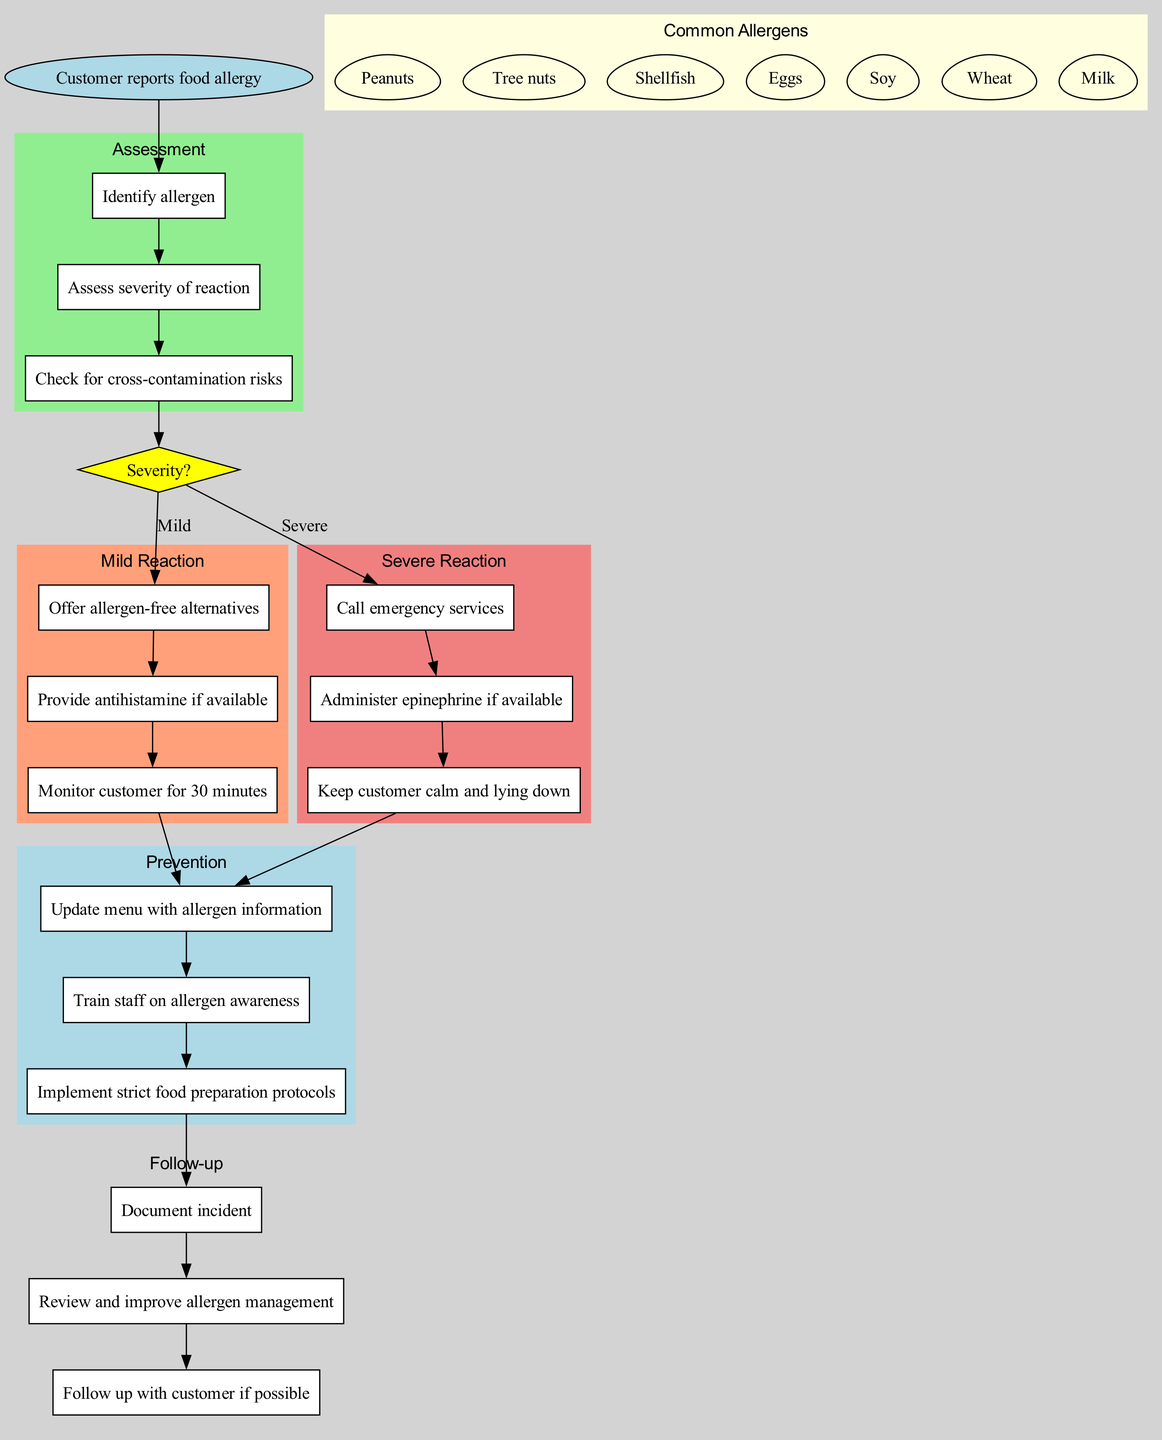What is the starting point of the clinical pathway? The starting point is explicitly defined in the diagram as "Customer reports food allergy," marking the initial entry into the clinical pathway.
Answer: Customer reports food allergy How many assessment steps are there? By counting the listed assessment steps under the "Assessment" cluster, there are three steps to be followed.
Answer: 3 What are the actions to take in case of a mild reaction? The diagram lists three specific actions to take for a mild reaction, providing a clear sequence to follow in this scenario.
Answer: Offer allergen-free alternatives, Provide antihistamine if available, Monitor customer for 30 minutes What is the first action to take for a severe reaction? The diagram indicates that the very first action to take in the severe reaction pathway is to "Call emergency services," making it the top priority in this situation.
Answer: Call emergency services What is the connection between mild reactions and prevention steps? The diagram shows that, after completing the actions for a mild reaction, there is a direct link from the last action in the mild reaction to the first prevention step. This indicates that prevention steps are intended to follow after addressing mild reactions.
Answer: Direct link to prevention steps What happens after calling emergency services in a severe reaction? Following the action of calling emergency services, the diagram indicates the subsequent action to be "Administer epinephrine if available," thus establishing the necessary follow-up steps in response to a severe allergic reaction.
Answer: Administer epinephrine if available How many common allergens are listed in the diagram? The diagram clearly specifies a list of common allergens, and by counting them, we find that there are seven allergens recognized in this clinical pathway.
Answer: 7 What is the last step in the follow-up actions? After reviewing all listed follow-up actions, the last action is to "Follow up with customer if possible," marking the conclusion of the follow-up protocol in case of food allergies.
Answer: Follow up with customer if possible What does the yellow diamond represent in the diagram? The yellow diamond labeled "Severity?" in the diagram functions as a decision point, determining the course of action based on whether the allergic reaction is mild or severe.
Answer: Decision point for severity 